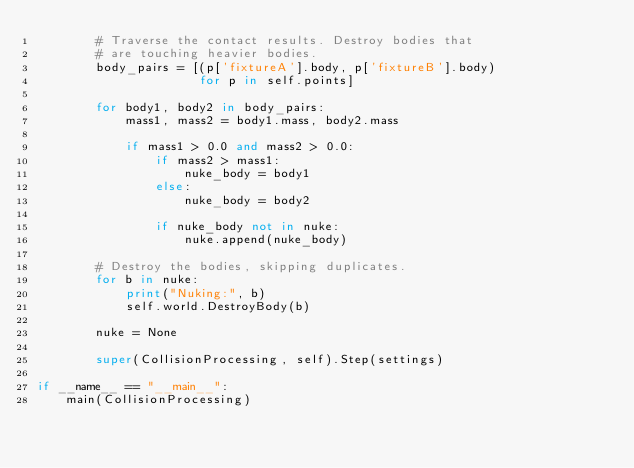Convert code to text. <code><loc_0><loc_0><loc_500><loc_500><_Python_>        # Traverse the contact results. Destroy bodies that
        # are touching heavier bodies.
        body_pairs = [(p['fixtureA'].body, p['fixtureB'].body)
                      for p in self.points]

        for body1, body2 in body_pairs:
            mass1, mass2 = body1.mass, body2.mass

            if mass1 > 0.0 and mass2 > 0.0:
                if mass2 > mass1:
                    nuke_body = body1
                else:
                    nuke_body = body2

                if nuke_body not in nuke:
                    nuke.append(nuke_body)

        # Destroy the bodies, skipping duplicates.
        for b in nuke:
            print("Nuking:", b)
            self.world.DestroyBody(b)

        nuke = None

        super(CollisionProcessing, self).Step(settings)

if __name__ == "__main__":
    main(CollisionProcessing)
</code> 